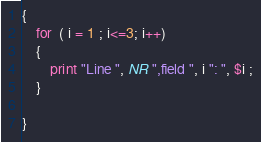<code> <loc_0><loc_0><loc_500><loc_500><_Awk_>{
	for  ( i = 1 ; i<=3; i++)
	{
		print "Line ", NR ",field ", i ": ", $i ;
	}

}
</code> 